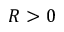<formula> <loc_0><loc_0><loc_500><loc_500>R > 0</formula> 